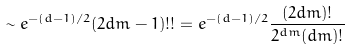<formula> <loc_0><loc_0><loc_500><loc_500>\sim e ^ { - ( d - 1 ) / 2 } ( 2 d m - 1 ) ! ! = e ^ { - ( d - 1 ) / 2 } \frac { ( 2 d m ) ! } { 2 ^ { d m } ( d m ) ! }</formula> 